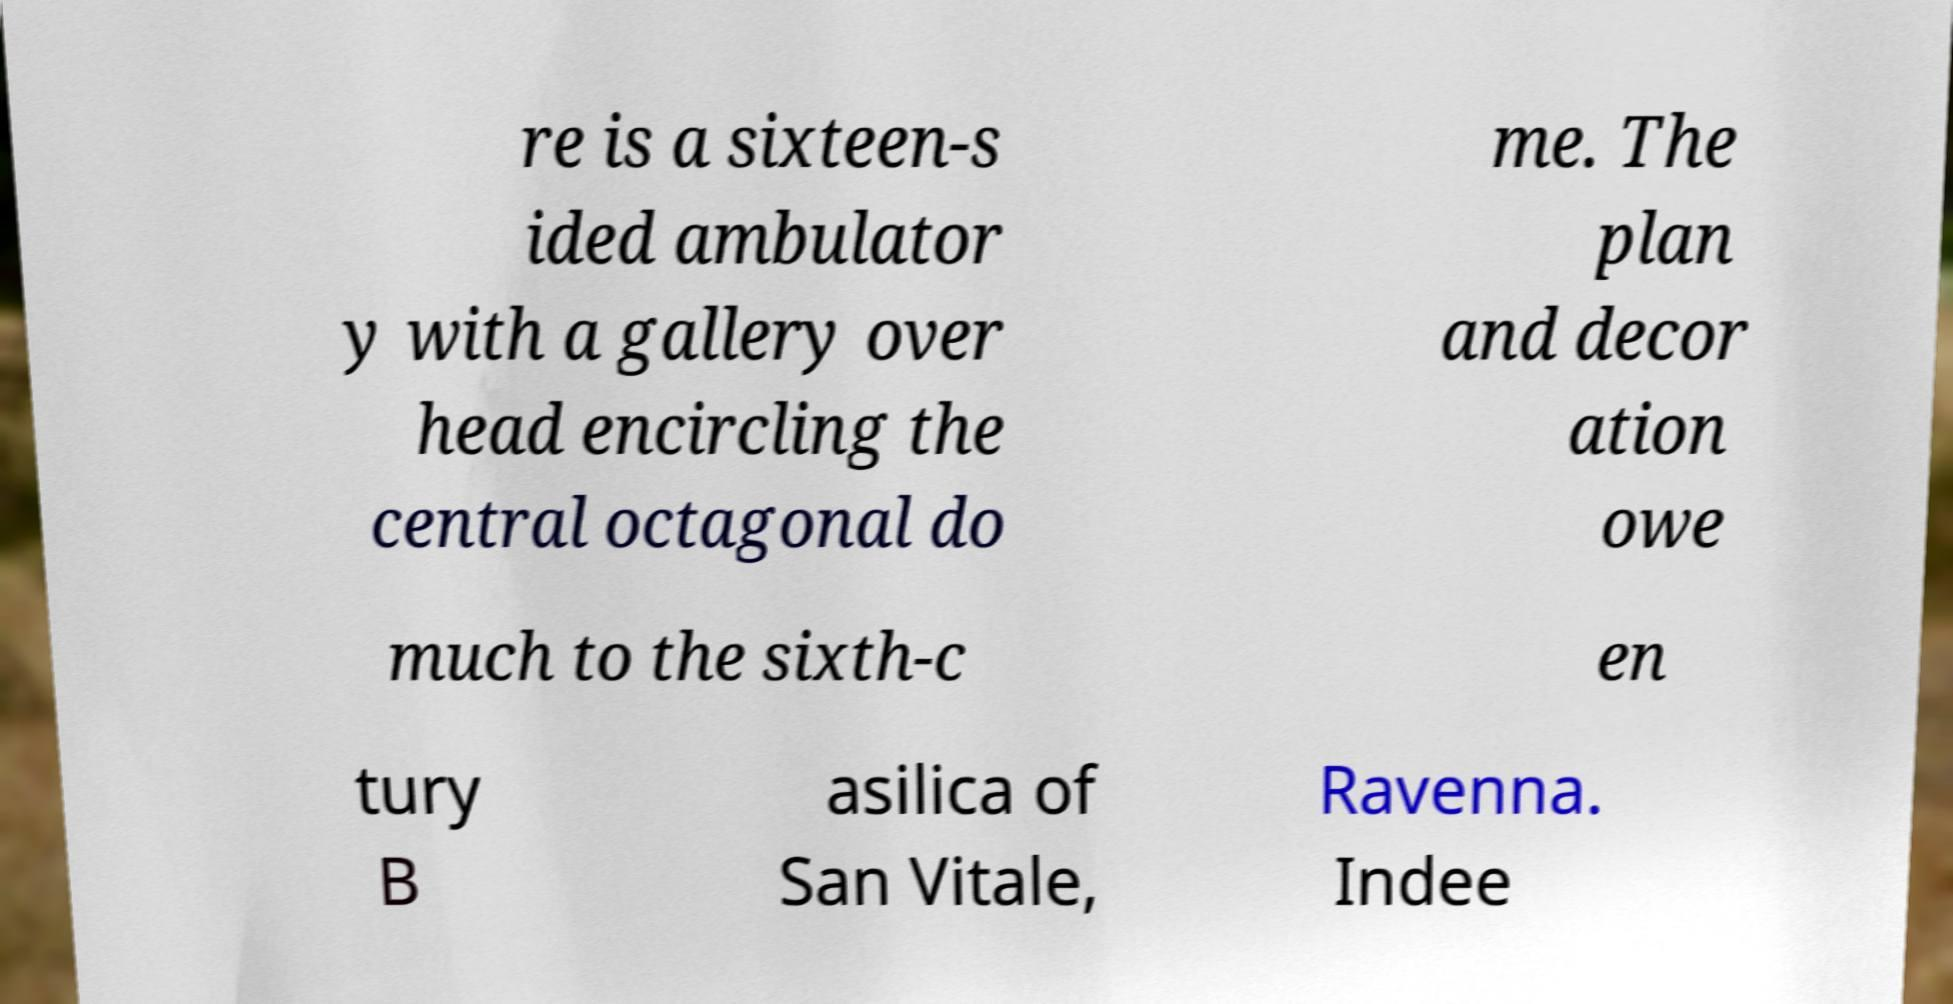What messages or text are displayed in this image? I need them in a readable, typed format. re is a sixteen-s ided ambulator y with a gallery over head encircling the central octagonal do me. The plan and decor ation owe much to the sixth-c en tury B asilica of San Vitale, Ravenna. Indee 